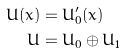Convert formula to latex. <formula><loc_0><loc_0><loc_500><loc_500>U ( x ) & = U ^ { \prime } _ { \bar { 0 } } ( x ) \\ U & = U _ { \bar { 0 } } \oplus U _ { \bar { 1 } }</formula> 